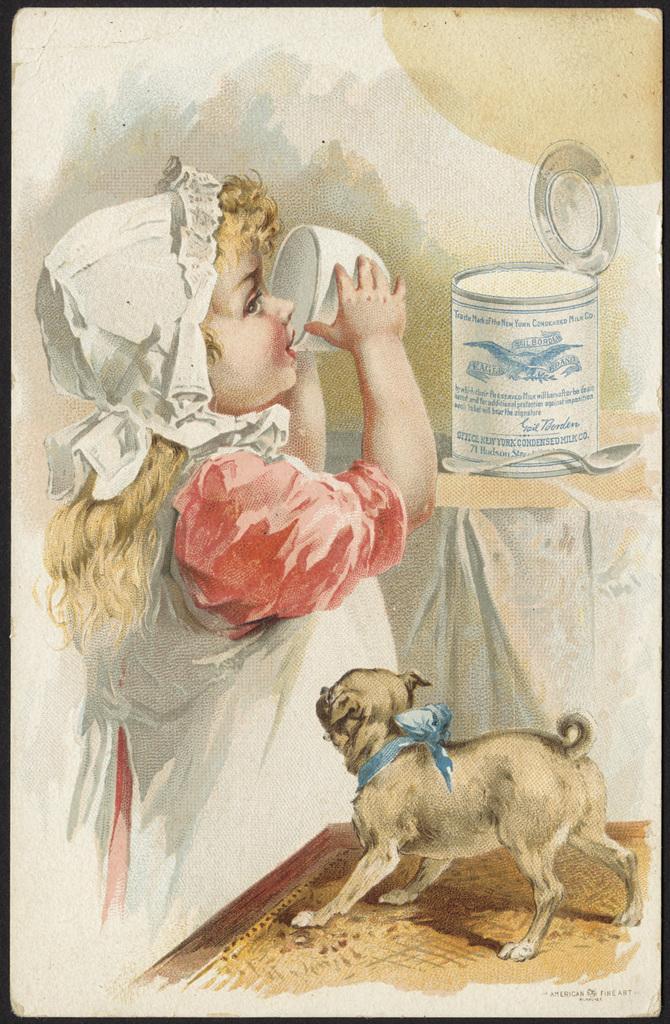Please provide a concise description of this image. In this picture we can see the drawing of a girl, dog, spoon, table, tin and a cup on the paper. At the bottom right corner of the paper, it is written something. 